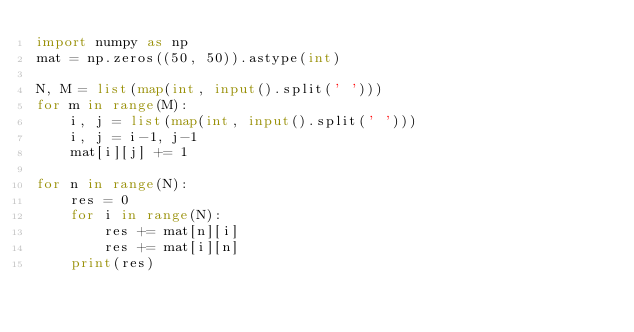<code> <loc_0><loc_0><loc_500><loc_500><_Python_>import numpy as np
mat = np.zeros((50, 50)).astype(int)

N, M = list(map(int, input().split(' ')))
for m in range(M):
    i, j = list(map(int, input().split(' ')))
    i, j = i-1, j-1
    mat[i][j] += 1
    
for n in range(N):
    res = 0
    for i in range(N):
        res += mat[n][i]
        res += mat[i][n]
    print(res)</code> 